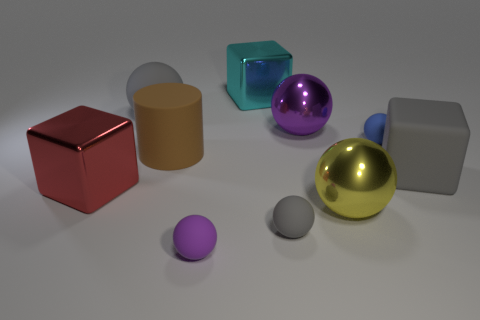What size is the purple ball that is the same material as the yellow ball?
Your response must be concise. Large. What number of small spheres are the same color as the large rubber sphere?
Your answer should be compact. 1. There is a purple thing that is to the left of the cyan shiny thing; is its size the same as the large yellow shiny object?
Ensure brevity in your answer.  No. There is a cube that is both to the left of the large yellow ball and in front of the cyan metallic object; what color is it?
Provide a succinct answer. Red. How many things are either brown metal cylinders or small objects right of the yellow shiny sphere?
Make the answer very short. 1. What material is the gray thing right of the metal ball in front of the metallic block to the left of the large brown rubber thing?
Your answer should be very brief. Rubber. Do the large ball that is in front of the purple metal object and the big matte cylinder have the same color?
Ensure brevity in your answer.  No. How many gray things are either small things or big matte blocks?
Give a very brief answer. 2. How many other things are the same shape as the yellow object?
Offer a terse response. 5. Is the material of the large brown cylinder the same as the large gray cube?
Ensure brevity in your answer.  Yes. 